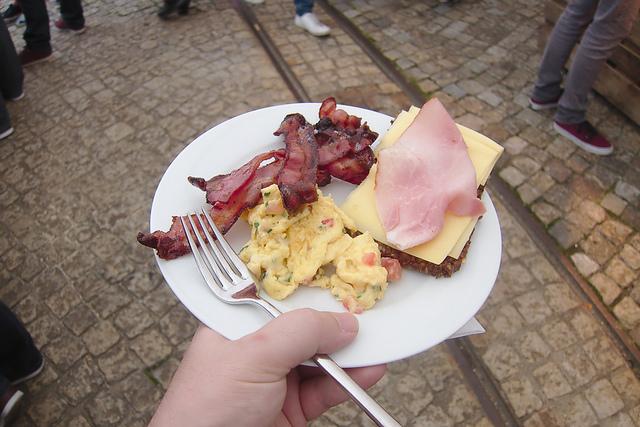What types of meat are on the plate?
Quick response, please. Bacon and ham. What color is the cheese?
Be succinct. Yellow. Which hand is being used to hold the plate?
Be succinct. Left. 